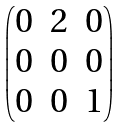<formula> <loc_0><loc_0><loc_500><loc_500>\begin{pmatrix} 0 & 2 & 0 \\ 0 & 0 & 0 \\ 0 & 0 & 1 \end{pmatrix}</formula> 